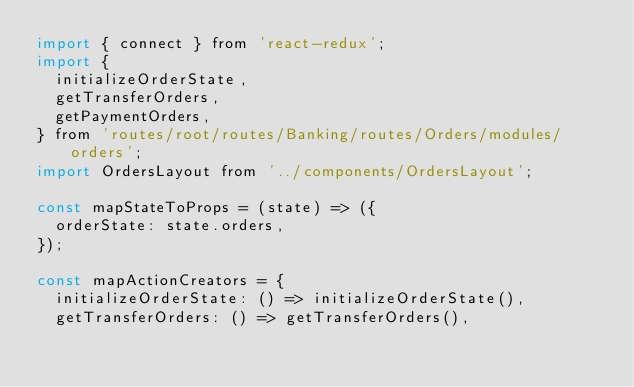Convert code to text. <code><loc_0><loc_0><loc_500><loc_500><_JavaScript_>import { connect } from 'react-redux';
import {
  initializeOrderState,
  getTransferOrders,
  getPaymentOrders,
} from 'routes/root/routes/Banking/routes/Orders/modules/orders';
import OrdersLayout from '../components/OrdersLayout';

const mapStateToProps = (state) => ({
  orderState: state.orders,
});

const mapActionCreators = {
  initializeOrderState: () => initializeOrderState(),
  getTransferOrders: () => getTransferOrders(),</code> 